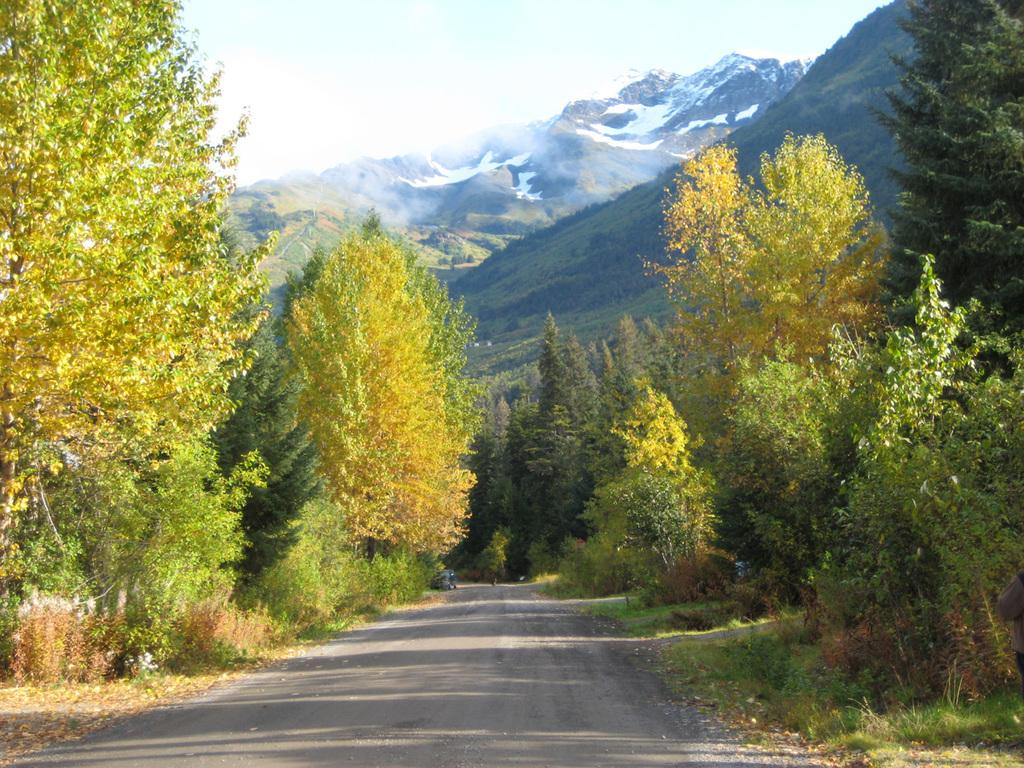What type of vegetation can be seen in the image? There is a group of trees and plants in the image. What can be seen in the background of the image? Hills and the sky are visible in the background of the image. What type of rose is growing on the bed in the image? There is no rose or bed present in the image. How does the digestion process of the plants in the image work? The image does not provide information about the digestion process of the plants; it only shows their appearance. 